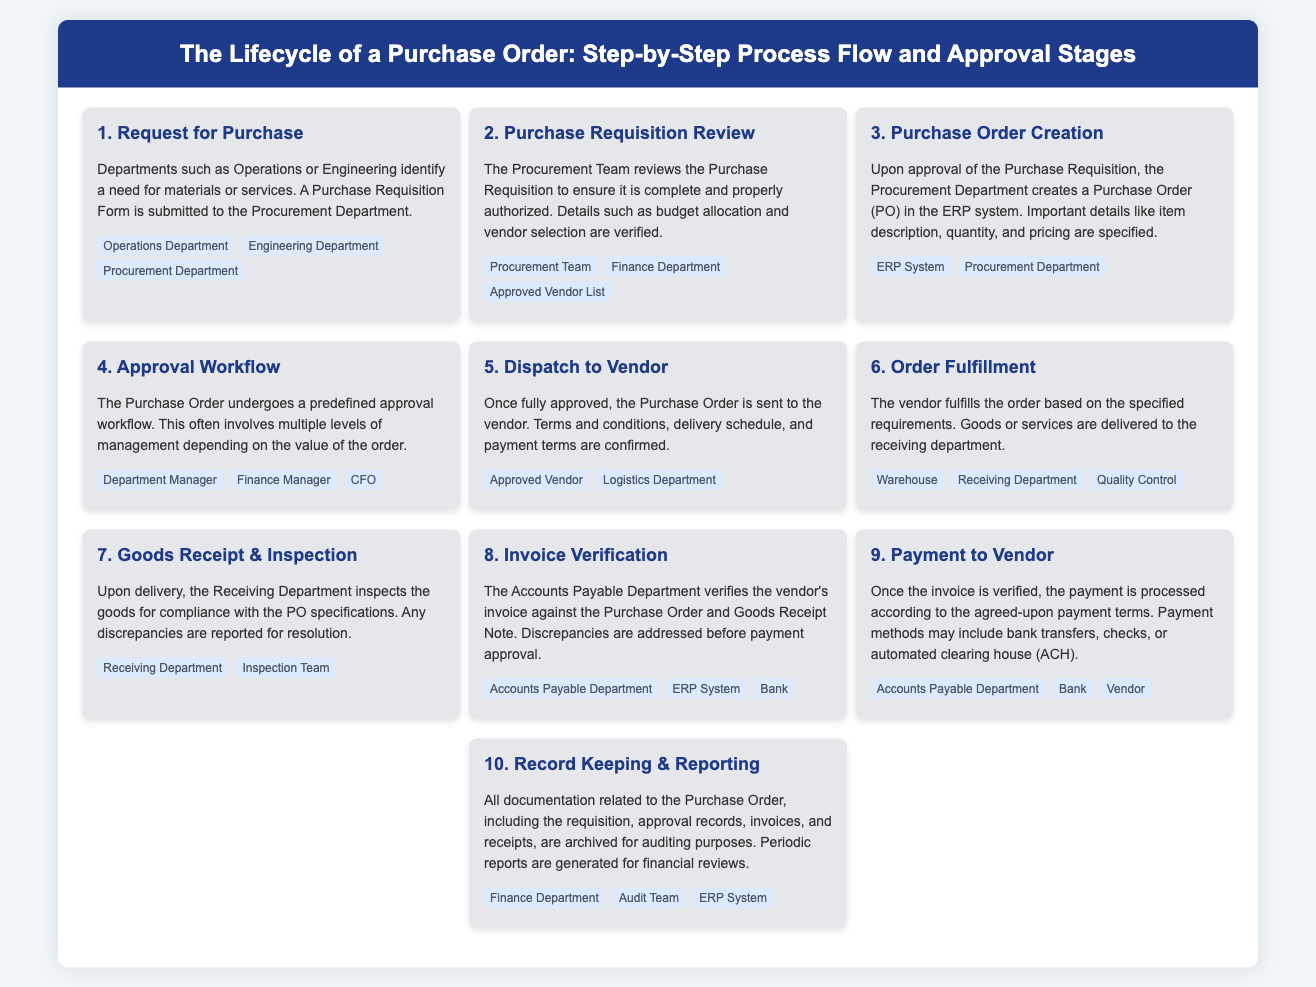What is the first step in the purchase order lifecycle? The first step is the "Request for Purchase," where departments identify a need and submit a Purchase Requisition Form.
Answer: Request for Purchase Who reviews the Purchase Requisition? The Procurement Team is responsible for reviewing the Purchase Requisition to ensure completeness and proper authorization.
Answer: Procurement Team What document is created after approving the Purchase Requisition? After the Purchase Requisition is approved, a Purchase Order (PO) is created in the ERP system.
Answer: Purchase Order (PO) Which department ensures the correctness of the vendor's invoice? The Accounts Payable Department verifies the vendor's invoice against the Purchase Order and Goods Receipt Note.
Answer: Accounts Payable Department What happens to the Purchase Order after it is fully approved? Once fully approved, the Purchase Order is dispatched to the vendor along with terms and conditions.
Answer: Dispatch to Vendor What role does the Quality Control team play in the order lifecycle? The Quality Control team inspects the goods that have been delivered to ensure compliance with the PO specifications.
Answer: Quality Control In which step is payment processed to the vendor? Payment to the vendor occurs in the "Payment to Vendor" step after the invoice is verified.
Answer: Payment to Vendor What must be done with all documentation related to the Purchase Order? All documentation must be archived for auditing purposes and periodic reports generated for financial reviews.
Answer: Record Keeping & Reporting How many main steps are there in the Purchase Order lifecycle? The infographic outlines a total of ten main steps in the Purchase Order lifecycle.
Answer: Ten Which department is involved in the final auditing process? The Audit Team handles the final auditing process involving all documentation related to the Purchase Order.
Answer: Audit Team 